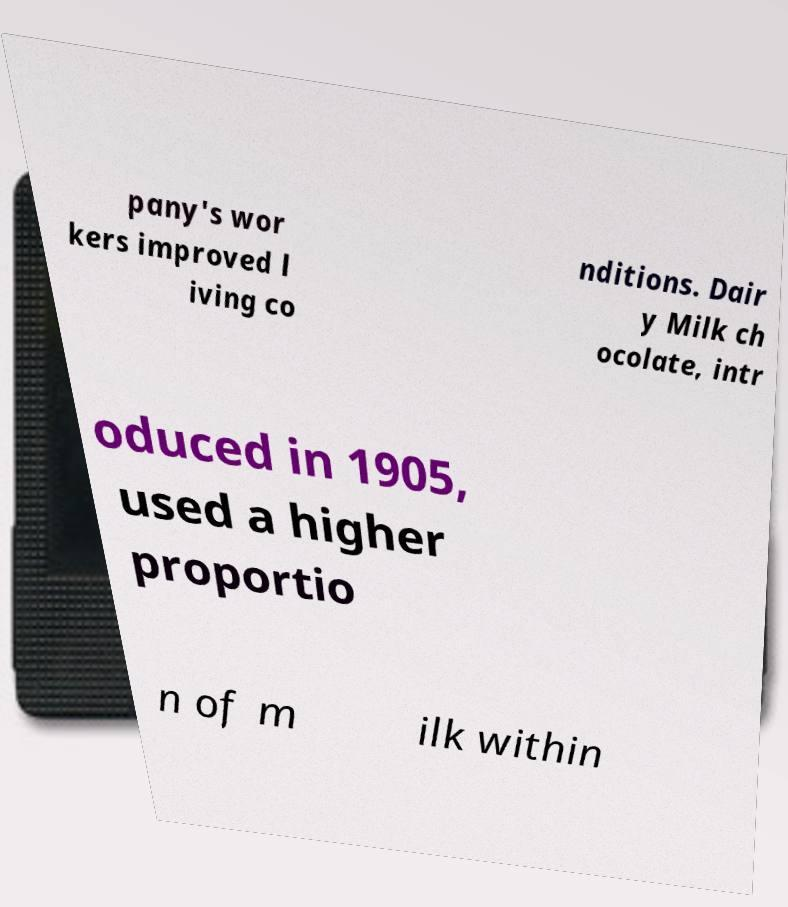There's text embedded in this image that I need extracted. Can you transcribe it verbatim? pany's wor kers improved l iving co nditions. Dair y Milk ch ocolate, intr oduced in 1905, used a higher proportio n of m ilk within 